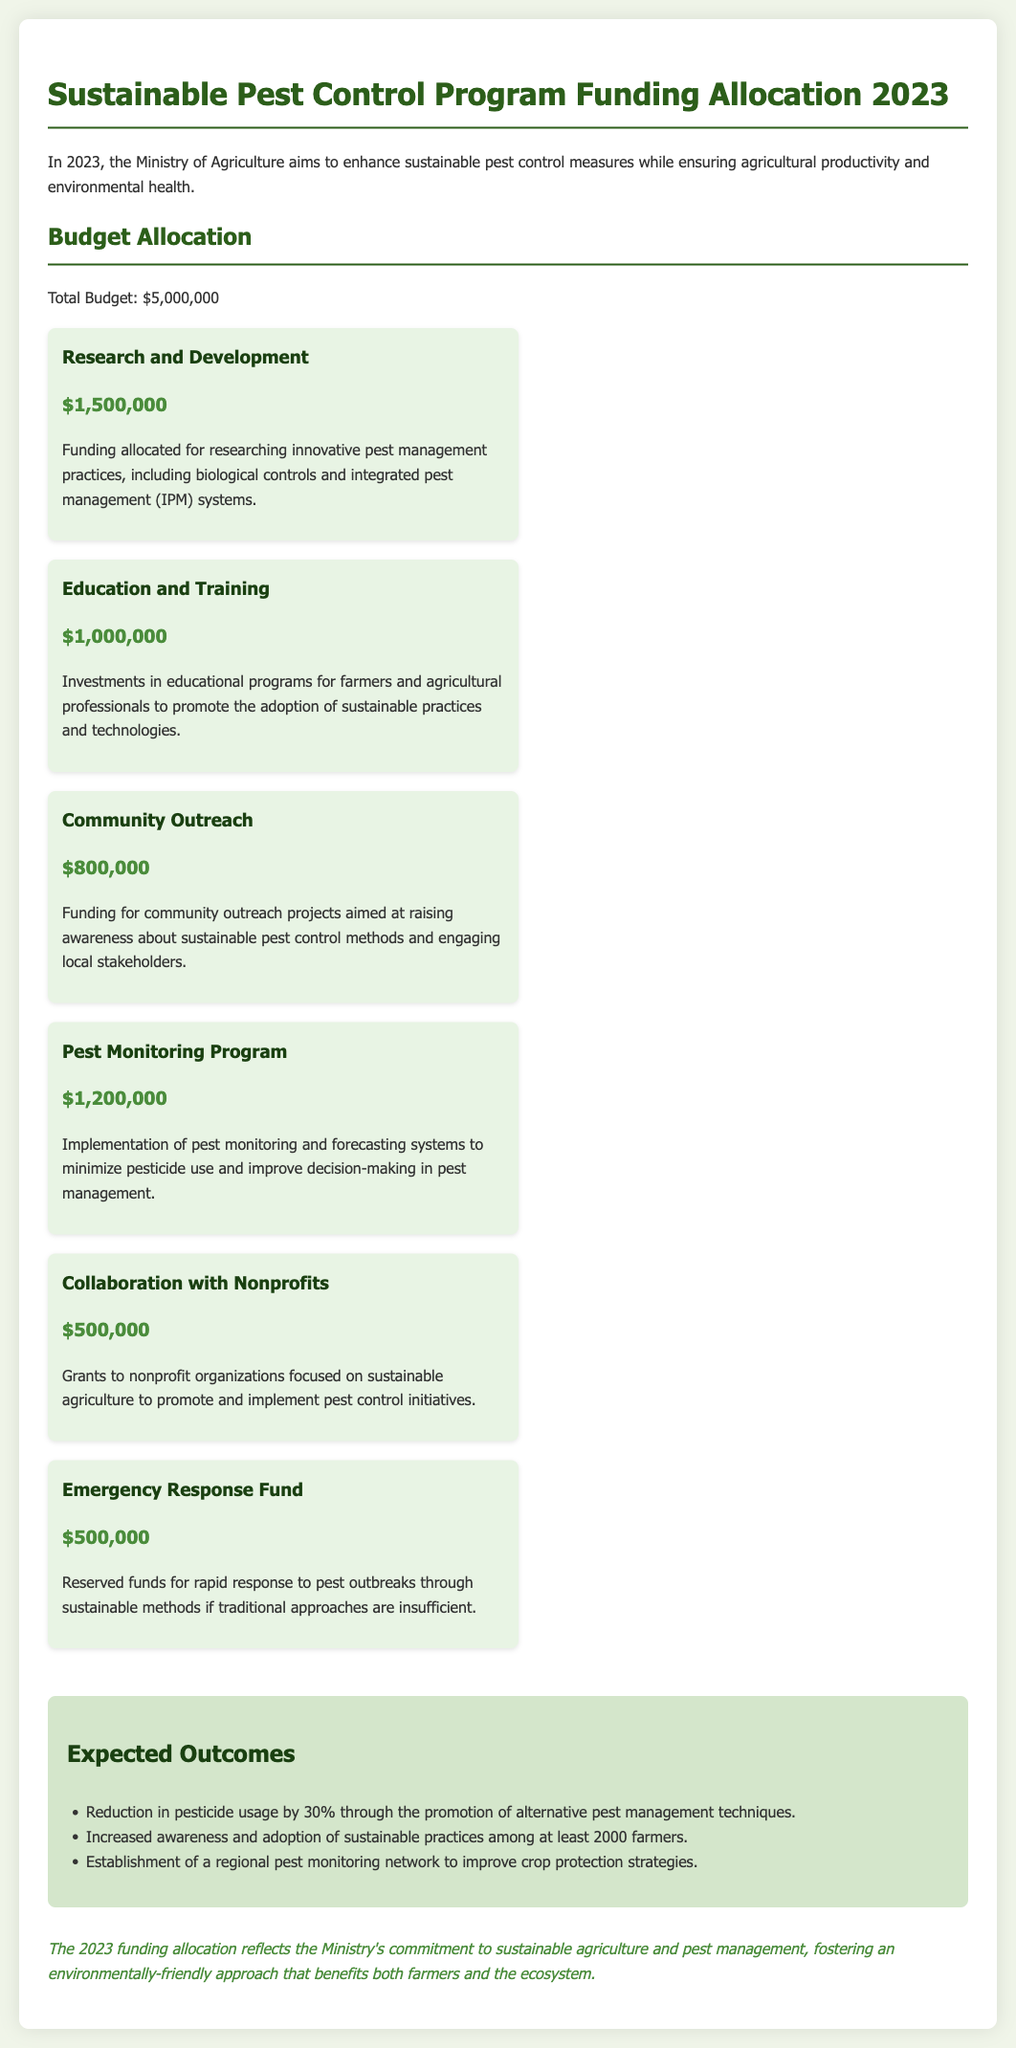What is the total budget for the program? The total budget is explicitly stated in the document as $5,000,000.
Answer: $5,000,000 How much funding is allocated for Research and Development? The document specifies that $1,500,000 is allocated for Research and Development.
Answer: $1,500,000 What is the expected reduction in pesticide usage? The expected reduction in pesticide usage is stated as 30%.
Answer: 30% How many farmers are expected to adopt sustainable practices? The document mentions that at least 2000 farmers are expected to adopt sustainable practices.
Answer: 2000 What is the amount set aside for the Emergency Response Fund? The document specifies that $500,000 is reserved for the Emergency Response Fund.
Answer: $500,000 What type of organizations will receive grants from the collaboration funding? The document mentions that grants will be provided to nonprofit organizations.
Answer: nonprofit organizations What is the primary goal of the Pest Monitoring Program funding? The primary goal of the Pest Monitoring Program funding is to minimize pesticide use.
Answer: minimize pesticide use What type of educational programs will the Education and Training funding support? The funding supports educational programs for farmers and agricultural professionals.
Answer: farmers and agricultural professionals 